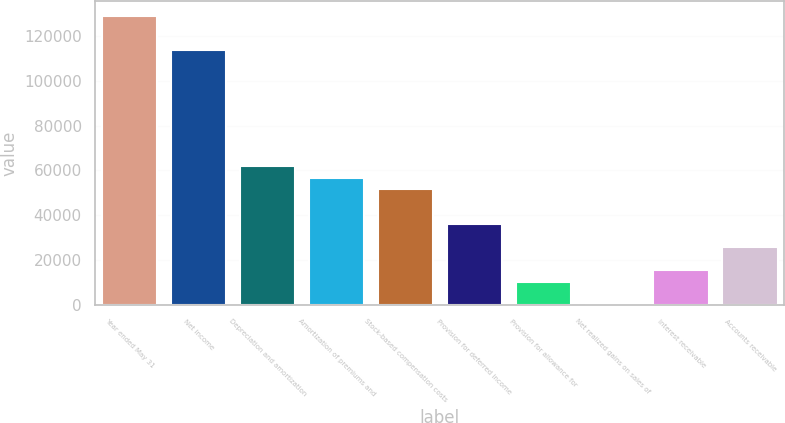Convert chart to OTSL. <chart><loc_0><loc_0><loc_500><loc_500><bar_chart><fcel>Year ended May 31<fcel>Net income<fcel>Depreciation and amortization<fcel>Amortization of premiums and<fcel>Stock-based compensation costs<fcel>Provision for deferred income<fcel>Provision for allowance for<fcel>Net realized gains on sales of<fcel>Interest receivable<fcel>Accounts receivable<nl><fcel>128982<fcel>113504<fcel>61911.5<fcel>56752.2<fcel>51592.9<fcel>36115.1<fcel>10318.7<fcel>0.1<fcel>15477.9<fcel>25796.5<nl></chart> 